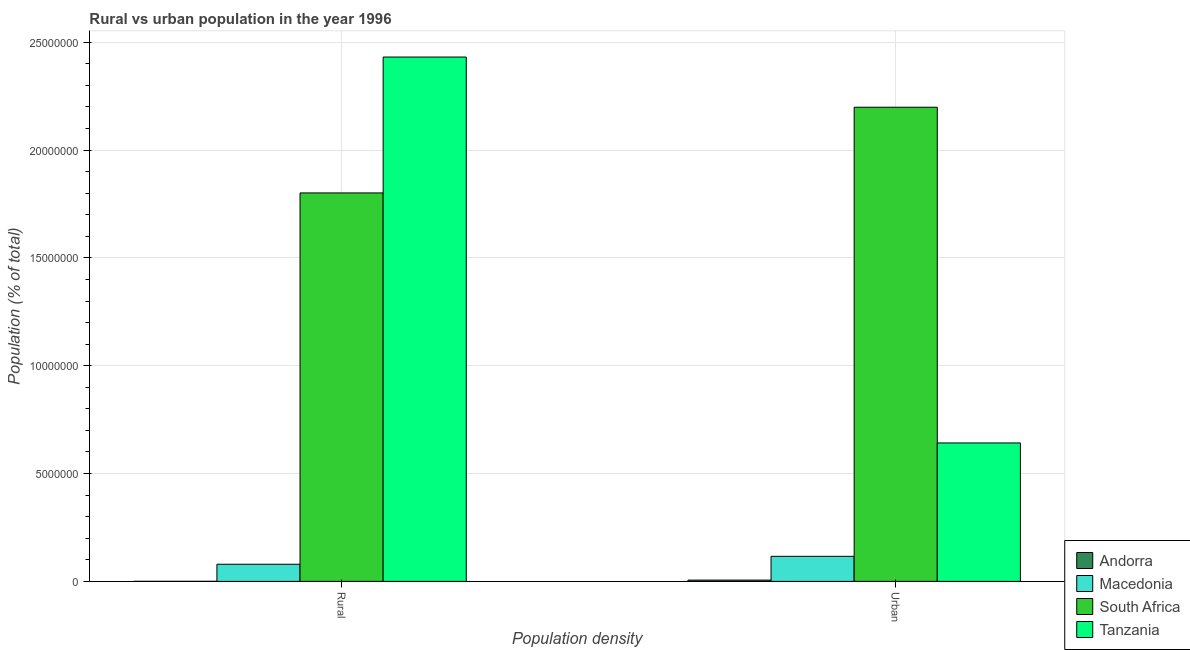How many different coloured bars are there?
Provide a short and direct response. 4. How many groups of bars are there?
Keep it short and to the point. 2. How many bars are there on the 2nd tick from the left?
Your answer should be very brief. 4. How many bars are there on the 1st tick from the right?
Offer a terse response. 4. What is the label of the 2nd group of bars from the left?
Your answer should be very brief. Urban. What is the urban population density in Macedonia?
Offer a terse response. 1.16e+06. Across all countries, what is the maximum urban population density?
Ensure brevity in your answer.  2.20e+07. Across all countries, what is the minimum rural population density?
Ensure brevity in your answer.  4227. In which country was the urban population density maximum?
Give a very brief answer. South Africa. In which country was the rural population density minimum?
Keep it short and to the point. Andorra. What is the total urban population density in the graph?
Offer a terse response. 2.96e+07. What is the difference between the rural population density in South Africa and that in Macedonia?
Ensure brevity in your answer.  1.72e+07. What is the difference between the urban population density in Macedonia and the rural population density in South Africa?
Ensure brevity in your answer.  -1.69e+07. What is the average urban population density per country?
Make the answer very short. 7.41e+06. What is the difference between the urban population density and rural population density in Tanzania?
Give a very brief answer. -1.79e+07. What is the ratio of the rural population density in Andorra to that in Macedonia?
Your answer should be very brief. 0.01. In how many countries, is the urban population density greater than the average urban population density taken over all countries?
Make the answer very short. 1. What does the 1st bar from the left in Rural represents?
Offer a very short reply. Andorra. What does the 1st bar from the right in Rural represents?
Offer a terse response. Tanzania. Are all the bars in the graph horizontal?
Ensure brevity in your answer.  No. What is the difference between two consecutive major ticks on the Y-axis?
Offer a very short reply. 5.00e+06. Are the values on the major ticks of Y-axis written in scientific E-notation?
Provide a short and direct response. No. Does the graph contain grids?
Keep it short and to the point. Yes. Where does the legend appear in the graph?
Your answer should be compact. Bottom right. How are the legend labels stacked?
Make the answer very short. Vertical. What is the title of the graph?
Give a very brief answer. Rural vs urban population in the year 1996. Does "Peru" appear as one of the legend labels in the graph?
Make the answer very short. No. What is the label or title of the X-axis?
Offer a terse response. Population density. What is the label or title of the Y-axis?
Offer a very short reply. Population (% of total). What is the Population (% of total) of Andorra in Rural?
Provide a short and direct response. 4227. What is the Population (% of total) in Macedonia in Rural?
Your response must be concise. 7.95e+05. What is the Population (% of total) of South Africa in Rural?
Ensure brevity in your answer.  1.80e+07. What is the Population (% of total) in Tanzania in Rural?
Provide a succinct answer. 2.43e+07. What is the Population (% of total) in Andorra in Urban?
Your answer should be very brief. 6.01e+04. What is the Population (% of total) in Macedonia in Urban?
Your response must be concise. 1.16e+06. What is the Population (% of total) in South Africa in Urban?
Your answer should be compact. 2.20e+07. What is the Population (% of total) of Tanzania in Urban?
Your answer should be compact. 6.42e+06. Across all Population density, what is the maximum Population (% of total) in Andorra?
Your answer should be compact. 6.01e+04. Across all Population density, what is the maximum Population (% of total) of Macedonia?
Provide a short and direct response. 1.16e+06. Across all Population density, what is the maximum Population (% of total) of South Africa?
Offer a very short reply. 2.20e+07. Across all Population density, what is the maximum Population (% of total) of Tanzania?
Offer a very short reply. 2.43e+07. Across all Population density, what is the minimum Population (% of total) in Andorra?
Ensure brevity in your answer.  4227. Across all Population density, what is the minimum Population (% of total) of Macedonia?
Your answer should be very brief. 7.95e+05. Across all Population density, what is the minimum Population (% of total) of South Africa?
Keep it short and to the point. 1.80e+07. Across all Population density, what is the minimum Population (% of total) of Tanzania?
Make the answer very short. 6.42e+06. What is the total Population (% of total) in Andorra in the graph?
Your answer should be very brief. 6.43e+04. What is the total Population (% of total) of Macedonia in the graph?
Make the answer very short. 1.96e+06. What is the total Population (% of total) of South Africa in the graph?
Provide a short and direct response. 4.00e+07. What is the total Population (% of total) of Tanzania in the graph?
Provide a succinct answer. 3.07e+07. What is the difference between the Population (% of total) of Andorra in Rural and that in Urban?
Offer a very short reply. -5.58e+04. What is the difference between the Population (% of total) of Macedonia in Rural and that in Urban?
Give a very brief answer. -3.67e+05. What is the difference between the Population (% of total) in South Africa in Rural and that in Urban?
Your response must be concise. -3.97e+06. What is the difference between the Population (% of total) of Tanzania in Rural and that in Urban?
Make the answer very short. 1.79e+07. What is the difference between the Population (% of total) of Andorra in Rural and the Population (% of total) of Macedonia in Urban?
Ensure brevity in your answer.  -1.16e+06. What is the difference between the Population (% of total) of Andorra in Rural and the Population (% of total) of South Africa in Urban?
Make the answer very short. -2.20e+07. What is the difference between the Population (% of total) of Andorra in Rural and the Population (% of total) of Tanzania in Urban?
Keep it short and to the point. -6.42e+06. What is the difference between the Population (% of total) of Macedonia in Rural and the Population (% of total) of South Africa in Urban?
Make the answer very short. -2.12e+07. What is the difference between the Population (% of total) in Macedonia in Rural and the Population (% of total) in Tanzania in Urban?
Your answer should be very brief. -5.62e+06. What is the difference between the Population (% of total) of South Africa in Rural and the Population (% of total) of Tanzania in Urban?
Your answer should be very brief. 1.16e+07. What is the average Population (% of total) in Andorra per Population density?
Your answer should be compact. 3.21e+04. What is the average Population (% of total) of Macedonia per Population density?
Give a very brief answer. 9.79e+05. What is the average Population (% of total) in South Africa per Population density?
Offer a terse response. 2.00e+07. What is the average Population (% of total) of Tanzania per Population density?
Provide a short and direct response. 1.54e+07. What is the difference between the Population (% of total) in Andorra and Population (% of total) in Macedonia in Rural?
Provide a succinct answer. -7.91e+05. What is the difference between the Population (% of total) of Andorra and Population (% of total) of South Africa in Rural?
Provide a short and direct response. -1.80e+07. What is the difference between the Population (% of total) in Andorra and Population (% of total) in Tanzania in Rural?
Provide a short and direct response. -2.43e+07. What is the difference between the Population (% of total) in Macedonia and Population (% of total) in South Africa in Rural?
Offer a terse response. -1.72e+07. What is the difference between the Population (% of total) in Macedonia and Population (% of total) in Tanzania in Rural?
Offer a terse response. -2.35e+07. What is the difference between the Population (% of total) of South Africa and Population (% of total) of Tanzania in Rural?
Your answer should be very brief. -6.30e+06. What is the difference between the Population (% of total) in Andorra and Population (% of total) in Macedonia in Urban?
Give a very brief answer. -1.10e+06. What is the difference between the Population (% of total) of Andorra and Population (% of total) of South Africa in Urban?
Offer a very short reply. -2.19e+07. What is the difference between the Population (% of total) of Andorra and Population (% of total) of Tanzania in Urban?
Ensure brevity in your answer.  -6.36e+06. What is the difference between the Population (% of total) of Macedonia and Population (% of total) of South Africa in Urban?
Your answer should be compact. -2.08e+07. What is the difference between the Population (% of total) of Macedonia and Population (% of total) of Tanzania in Urban?
Provide a short and direct response. -5.26e+06. What is the difference between the Population (% of total) in South Africa and Population (% of total) in Tanzania in Urban?
Keep it short and to the point. 1.56e+07. What is the ratio of the Population (% of total) in Andorra in Rural to that in Urban?
Your answer should be compact. 0.07. What is the ratio of the Population (% of total) of Macedonia in Rural to that in Urban?
Ensure brevity in your answer.  0.68. What is the ratio of the Population (% of total) in South Africa in Rural to that in Urban?
Ensure brevity in your answer.  0.82. What is the ratio of the Population (% of total) of Tanzania in Rural to that in Urban?
Offer a terse response. 3.79. What is the difference between the highest and the second highest Population (% of total) in Andorra?
Provide a succinct answer. 5.58e+04. What is the difference between the highest and the second highest Population (% of total) in Macedonia?
Ensure brevity in your answer.  3.67e+05. What is the difference between the highest and the second highest Population (% of total) of South Africa?
Your response must be concise. 3.97e+06. What is the difference between the highest and the second highest Population (% of total) in Tanzania?
Your response must be concise. 1.79e+07. What is the difference between the highest and the lowest Population (% of total) of Andorra?
Make the answer very short. 5.58e+04. What is the difference between the highest and the lowest Population (% of total) of Macedonia?
Give a very brief answer. 3.67e+05. What is the difference between the highest and the lowest Population (% of total) of South Africa?
Make the answer very short. 3.97e+06. What is the difference between the highest and the lowest Population (% of total) of Tanzania?
Provide a succinct answer. 1.79e+07. 